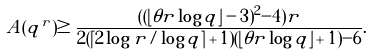<formula> <loc_0><loc_0><loc_500><loc_500>A ( q ^ { r } ) \geq \frac { ( ( \lfloor \theta r \log q \rfloor - 3 ) ^ { 2 } - 4 ) r } { 2 ( \lceil 2 \log r / \log q \rceil + 1 ) ( \lfloor \theta r \log q \rfloor + 1 ) - 6 } .</formula> 